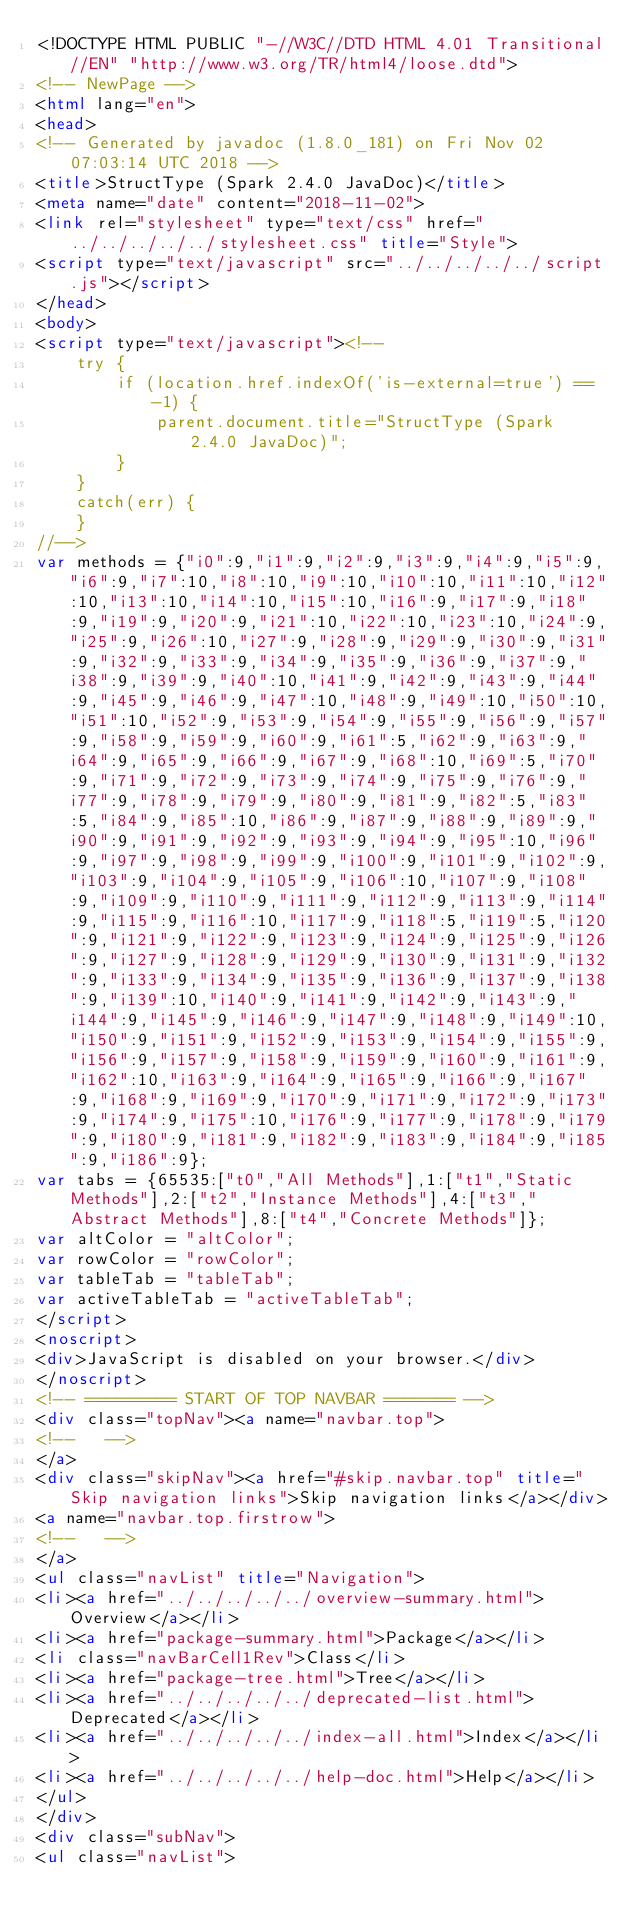Convert code to text. <code><loc_0><loc_0><loc_500><loc_500><_HTML_><!DOCTYPE HTML PUBLIC "-//W3C//DTD HTML 4.01 Transitional//EN" "http://www.w3.org/TR/html4/loose.dtd">
<!-- NewPage -->
<html lang="en">
<head>
<!-- Generated by javadoc (1.8.0_181) on Fri Nov 02 07:03:14 UTC 2018 -->
<title>StructType (Spark 2.4.0 JavaDoc)</title>
<meta name="date" content="2018-11-02">
<link rel="stylesheet" type="text/css" href="../../../../../stylesheet.css" title="Style">
<script type="text/javascript" src="../../../../../script.js"></script>
</head>
<body>
<script type="text/javascript"><!--
    try {
        if (location.href.indexOf('is-external=true') == -1) {
            parent.document.title="StructType (Spark 2.4.0 JavaDoc)";
        }
    }
    catch(err) {
    }
//-->
var methods = {"i0":9,"i1":9,"i2":9,"i3":9,"i4":9,"i5":9,"i6":9,"i7":10,"i8":10,"i9":10,"i10":10,"i11":10,"i12":10,"i13":10,"i14":10,"i15":10,"i16":9,"i17":9,"i18":9,"i19":9,"i20":9,"i21":10,"i22":10,"i23":10,"i24":9,"i25":9,"i26":10,"i27":9,"i28":9,"i29":9,"i30":9,"i31":9,"i32":9,"i33":9,"i34":9,"i35":9,"i36":9,"i37":9,"i38":9,"i39":9,"i40":10,"i41":9,"i42":9,"i43":9,"i44":9,"i45":9,"i46":9,"i47":10,"i48":9,"i49":10,"i50":10,"i51":10,"i52":9,"i53":9,"i54":9,"i55":9,"i56":9,"i57":9,"i58":9,"i59":9,"i60":9,"i61":5,"i62":9,"i63":9,"i64":9,"i65":9,"i66":9,"i67":9,"i68":10,"i69":5,"i70":9,"i71":9,"i72":9,"i73":9,"i74":9,"i75":9,"i76":9,"i77":9,"i78":9,"i79":9,"i80":9,"i81":9,"i82":5,"i83":5,"i84":9,"i85":10,"i86":9,"i87":9,"i88":9,"i89":9,"i90":9,"i91":9,"i92":9,"i93":9,"i94":9,"i95":10,"i96":9,"i97":9,"i98":9,"i99":9,"i100":9,"i101":9,"i102":9,"i103":9,"i104":9,"i105":9,"i106":10,"i107":9,"i108":9,"i109":9,"i110":9,"i111":9,"i112":9,"i113":9,"i114":9,"i115":9,"i116":10,"i117":9,"i118":5,"i119":5,"i120":9,"i121":9,"i122":9,"i123":9,"i124":9,"i125":9,"i126":9,"i127":9,"i128":9,"i129":9,"i130":9,"i131":9,"i132":9,"i133":9,"i134":9,"i135":9,"i136":9,"i137":9,"i138":9,"i139":10,"i140":9,"i141":9,"i142":9,"i143":9,"i144":9,"i145":9,"i146":9,"i147":9,"i148":9,"i149":10,"i150":9,"i151":9,"i152":9,"i153":9,"i154":9,"i155":9,"i156":9,"i157":9,"i158":9,"i159":9,"i160":9,"i161":9,"i162":10,"i163":9,"i164":9,"i165":9,"i166":9,"i167":9,"i168":9,"i169":9,"i170":9,"i171":9,"i172":9,"i173":9,"i174":9,"i175":10,"i176":9,"i177":9,"i178":9,"i179":9,"i180":9,"i181":9,"i182":9,"i183":9,"i184":9,"i185":9,"i186":9};
var tabs = {65535:["t0","All Methods"],1:["t1","Static Methods"],2:["t2","Instance Methods"],4:["t3","Abstract Methods"],8:["t4","Concrete Methods"]};
var altColor = "altColor";
var rowColor = "rowColor";
var tableTab = "tableTab";
var activeTableTab = "activeTableTab";
</script>
<noscript>
<div>JavaScript is disabled on your browser.</div>
</noscript>
<!-- ========= START OF TOP NAVBAR ======= -->
<div class="topNav"><a name="navbar.top">
<!--   -->
</a>
<div class="skipNav"><a href="#skip.navbar.top" title="Skip navigation links">Skip navigation links</a></div>
<a name="navbar.top.firstrow">
<!--   -->
</a>
<ul class="navList" title="Navigation">
<li><a href="../../../../../overview-summary.html">Overview</a></li>
<li><a href="package-summary.html">Package</a></li>
<li class="navBarCell1Rev">Class</li>
<li><a href="package-tree.html">Tree</a></li>
<li><a href="../../../../../deprecated-list.html">Deprecated</a></li>
<li><a href="../../../../../index-all.html">Index</a></li>
<li><a href="../../../../../help-doc.html">Help</a></li>
</ul>
</div>
<div class="subNav">
<ul class="navList"></code> 